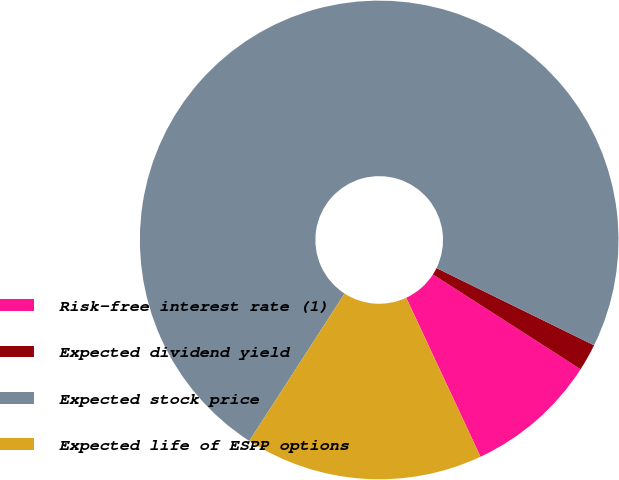<chart> <loc_0><loc_0><loc_500><loc_500><pie_chart><fcel>Risk-free interest rate (1)<fcel>Expected dividend yield<fcel>Expected stock price<fcel>Expected life of ESPP options<nl><fcel>8.96%<fcel>1.83%<fcel>73.13%<fcel>16.09%<nl></chart> 